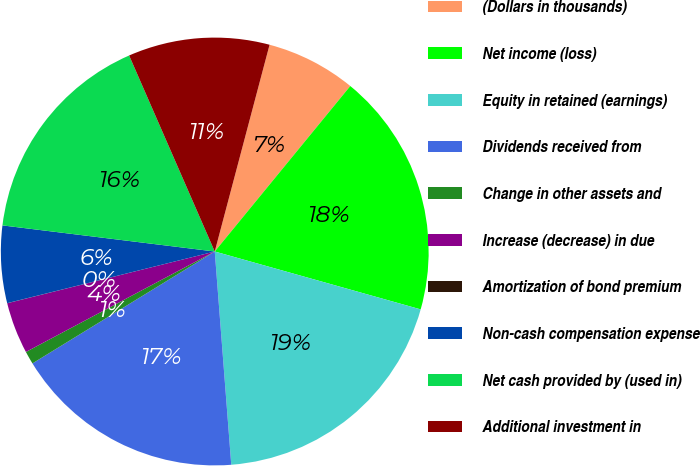Convert chart to OTSL. <chart><loc_0><loc_0><loc_500><loc_500><pie_chart><fcel>(Dollars in thousands)<fcel>Net income (loss)<fcel>Equity in retained (earnings)<fcel>Dividends received from<fcel>Change in other assets and<fcel>Increase (decrease) in due<fcel>Amortization of bond premium<fcel>Non-cash compensation expense<fcel>Net cash provided by (used in)<fcel>Additional investment in<nl><fcel>6.8%<fcel>18.44%<fcel>19.41%<fcel>17.47%<fcel>0.98%<fcel>3.89%<fcel>0.01%<fcel>5.83%<fcel>16.5%<fcel>10.68%<nl></chart> 